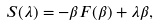<formula> <loc_0><loc_0><loc_500><loc_500>S ( \lambda ) = - \beta F ( \beta ) + { \lambda } \beta ,</formula> 